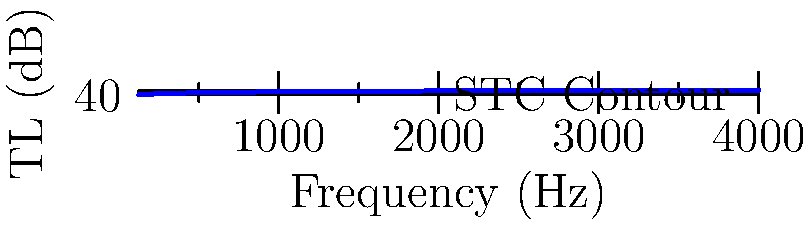A multi-layered wall assembly has the following Transmission Loss (TL) values at different frequencies:

125 Hz: 25 dB
250 Hz: 33 dB
500 Hz: 39 dB
1000 Hz: 45 dB
2000 Hz: 50 dB
4000 Hz: 54 dB

Using the STC contour method, determine the Sound Transmission Class (STC) rating of this wall assembly. Assume that no single TL value falls more than 8 dB below the STC contour, and the sum of all deficiencies is less than 32 dB. To determine the Sound Transmission Class (STC) rating, we follow these steps:

1. Plot the given TL values on a graph (as shown in the provided image).

2. The STC contour is a reference curve that we need to fit to our data points. We start by positioning the contour such that the sum of deficiencies (where data points fall below the contour) is as large as possible without exceeding 32 dB, and no single deficiency is greater than 8 dB.

3. We typically start with a high STC value and move the contour down until we find the highest STC that meets the criteria.

4. Let's start with STC 50:
   - At 125 Hz: Deficiency = 30 - 25 = 5 dB
   - At 250 Hz: Deficiency = 39 - 33 = 6 dB
   - At 500 Hz: Deficiency = 48 - 39 = 9 dB (exceeds 8 dB limit)

5. We need to lower the STC. Let's try STC 48:
   - At 125 Hz: Deficiency = 28 - 25 = 3 dB
   - At 250 Hz: Deficiency = 37 - 33 = 4 dB
   - At 500 Hz: Deficiency = 46 - 39 = 7 dB
   - No deficiencies at higher frequencies
   - Sum of deficiencies: 3 + 4 + 7 = 14 dB (less than 32 dB)

6. STC 48 meets all criteria: no single deficiency exceeds 8 dB, and the sum of deficiencies is less than 32 dB.

7. Trying STC 49 would result in a deficiency greater than 8 dB at 500 Hz.

Therefore, the highest STC rating that meets all criteria is 48.
Answer: STC 48 